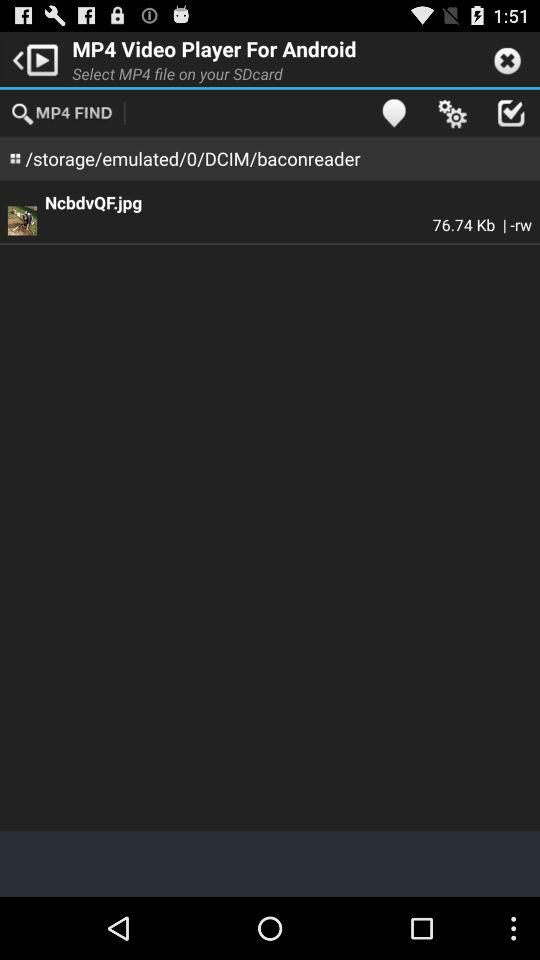What is the name of the image? The name of the image is NcbdvQF.jpg. 